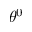Convert formula to latex. <formula><loc_0><loc_0><loc_500><loc_500>\theta ^ { 0 }</formula> 